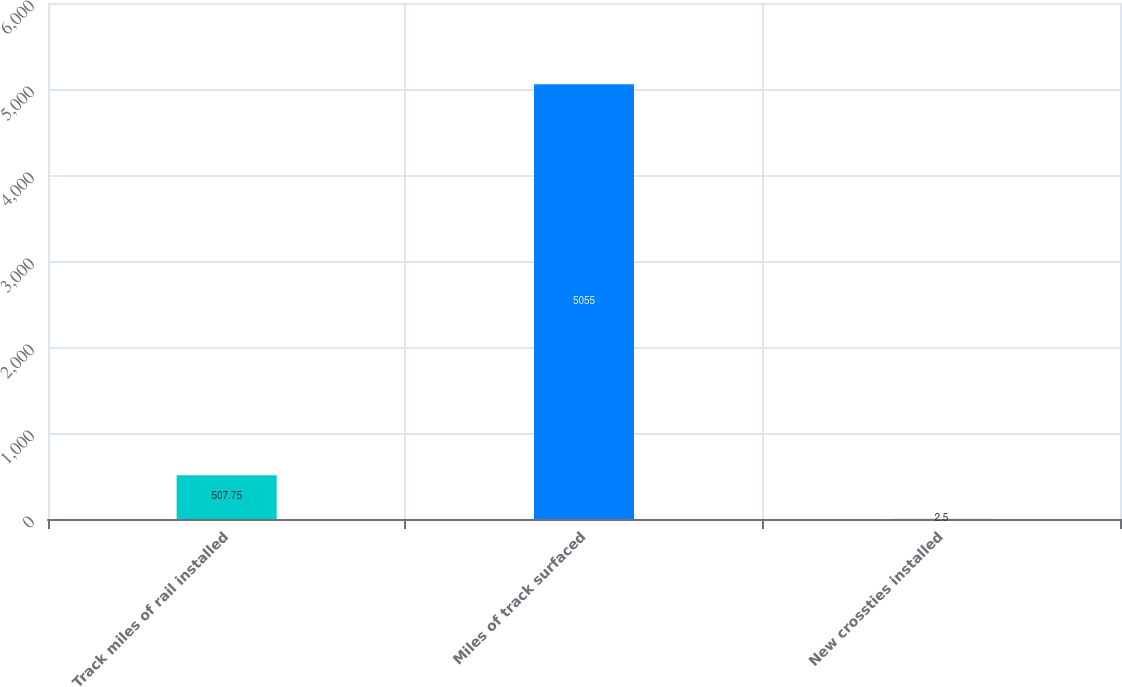Convert chart to OTSL. <chart><loc_0><loc_0><loc_500><loc_500><bar_chart><fcel>Track miles of rail installed<fcel>Miles of track surfaced<fcel>New crossties installed<nl><fcel>507.75<fcel>5055<fcel>2.5<nl></chart> 